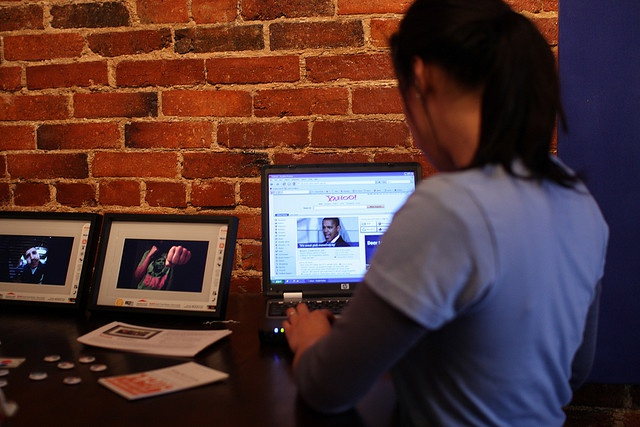Describe the objects in this image and their specific colors. I can see people in maroon, black, gray, and navy tones, laptop in maroon, lightblue, and black tones, laptop in maroon, black, tan, and gray tones, laptop in maroon, black, gray, tan, and brown tones, and keyboard in maroon, black, and brown tones in this image. 